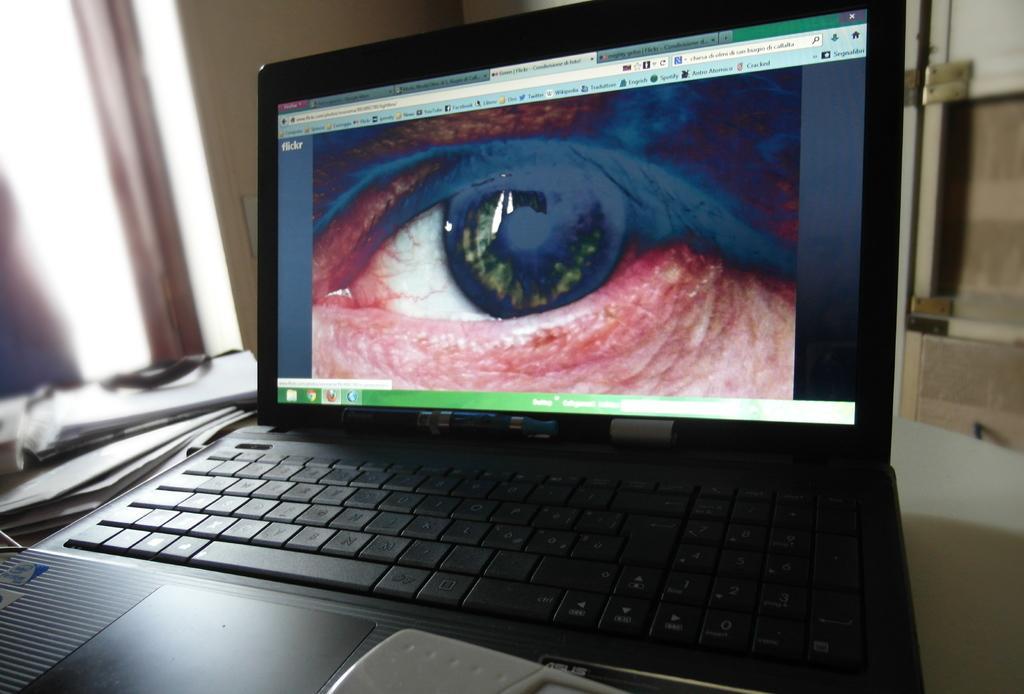Can you describe this image briefly? In this picture we can see a laptop in the front, there is a picture of a human eye on the screen, on the left side there are papers, we can see a blurry background. 